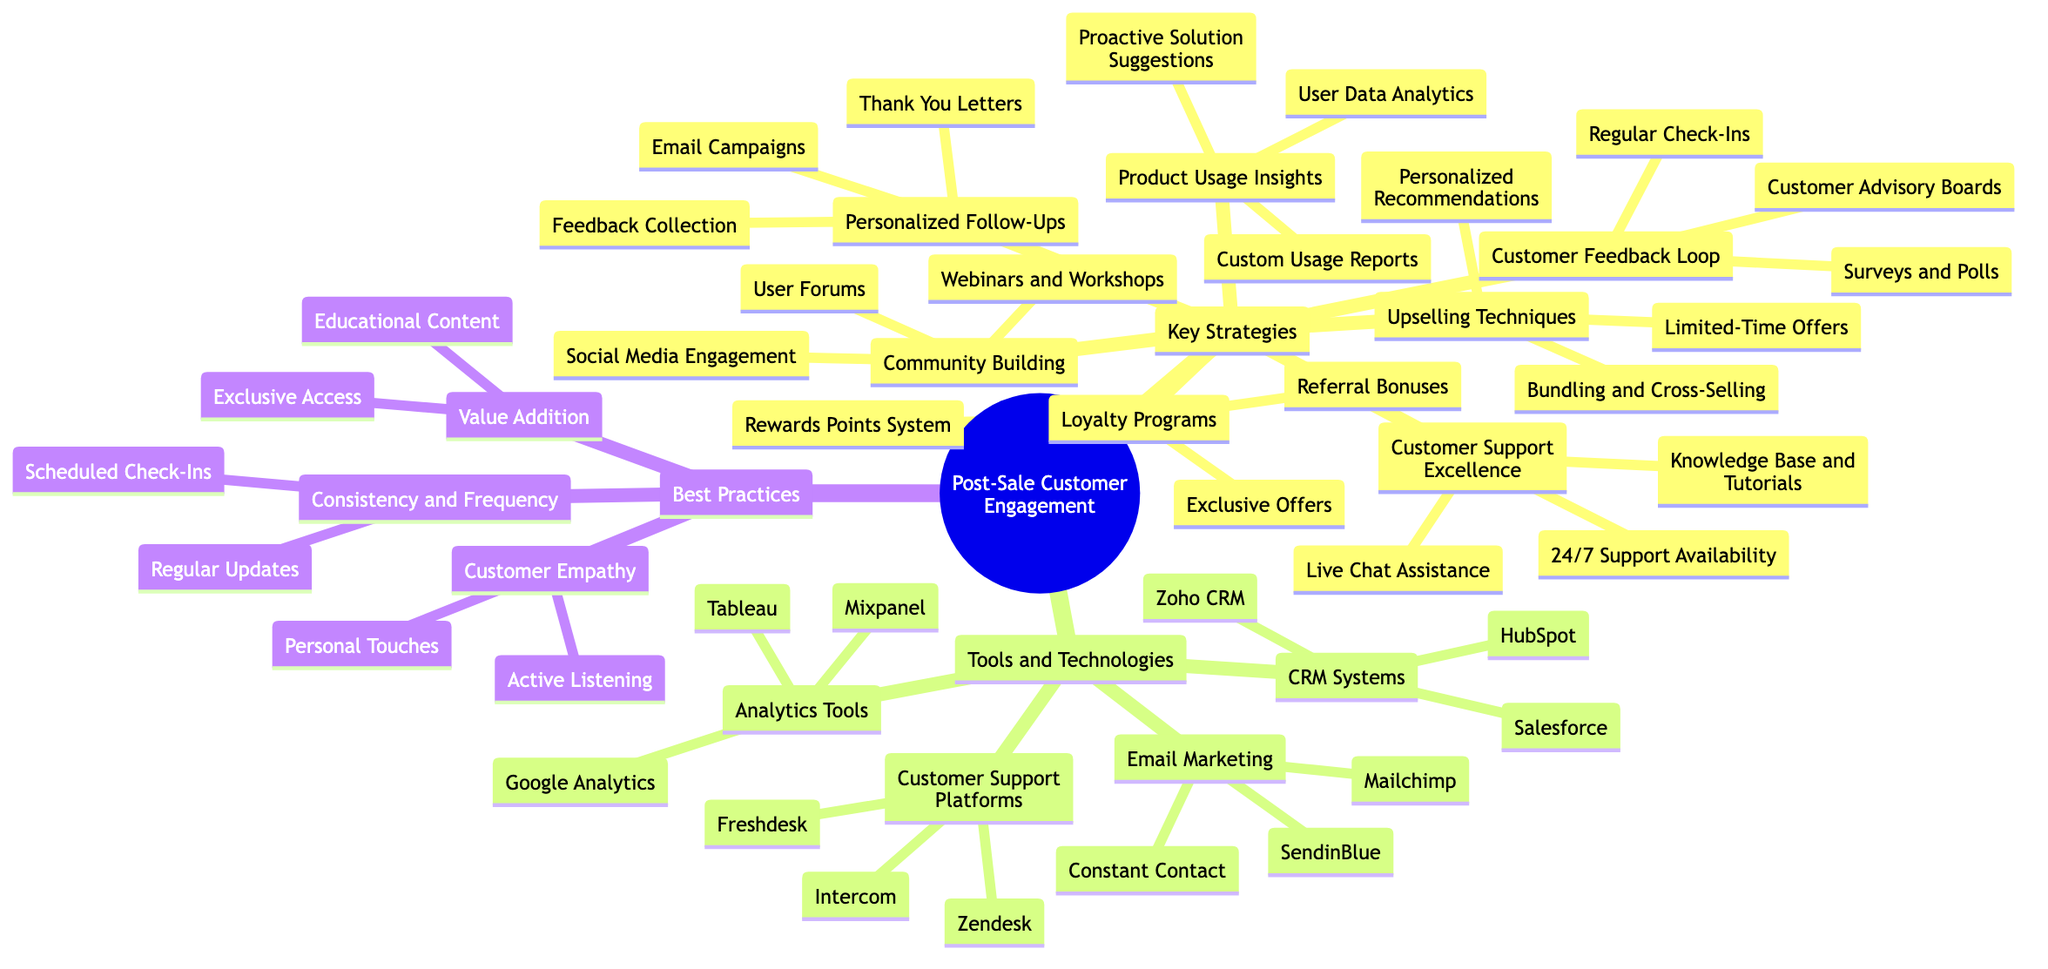What are the three key strategies for post-sale customer engagement? The diagram lists "Key Strategies" with several categories underneath. The first three listed are "Personalized Follow-Ups," "Customer Support Excellence," and "Loyalty Programs."
Answer: Personalized Follow-Ups, Customer Support Excellence, Loyalty Programs How many tools are listed under CRM Systems? Under the "Tools and Technologies" section, there are three specific tools mentioned under "CRM Systems": "Salesforce," "HubSpot," and "Zoho CRM." Thus, the total count is three.
Answer: 3 What type of insights does "Product Usage Insights" provide? "Product Usage Insights" includes three components: "User Data Analytics," "Custom Usage Reports," and "Proactive Solution Suggestions." These collectively indicate that the insights are focused on product usage and performance.
Answer: User Data Analytics, Custom Usage Reports, Proactive Solution Suggestions Which type of engagement strategy is related to community-building? The section titled "Community Building" lists three methods: "User Forums," "Webinars and Workshops," and "Social Media Engagement." These methods are aimed at fostering a community among users.
Answer: User Forums, Webinars and Workshops, Social Media Engagement What are two tools mentioned for Customer Support Platforms? In the "Tools and Technologies" section under "Customer Support Platforms," two examples are "Zendesk" and "Freshdesk." These are specific tools for managing customer support.
Answer: Zendesk, Freshdesk How are "Feedback Collection" and "Surveys and Polls" connected? "Feedback Collection" is listed under "Personalized Follow-Ups," while "Surveys and Polls" is part of the "Customer Feedback Loop." Both are methods for gathering customer opinions and insights to enhance engagement.
Answer: Feedback Collection is under Personalized Follow-Ups; Surveys and Polls are under Customer Feedback Loop What is emphasized in the Best Practices section? The "Best Practices" section includes "Consistency and Frequency," "Value Addition," and "Customer Empathy," which highlight the crucial approaches during post-sale engagement.
Answer: Consistency and Frequency, Value Addition, Customer Empathy Which strategy includes 'Limited-Time Offers'? The strategy that includes "Limited-Time Offers" is "Upselling Techniques," which suggests tactical approaches to increase sales to existing customers.
Answer: Upselling Techniques 